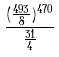Convert formula to latex. <formula><loc_0><loc_0><loc_500><loc_500>\frac { ( \frac { 4 9 3 } { 8 } ) ^ { 4 7 0 } } { \frac { 3 1 } { 4 } }</formula> 